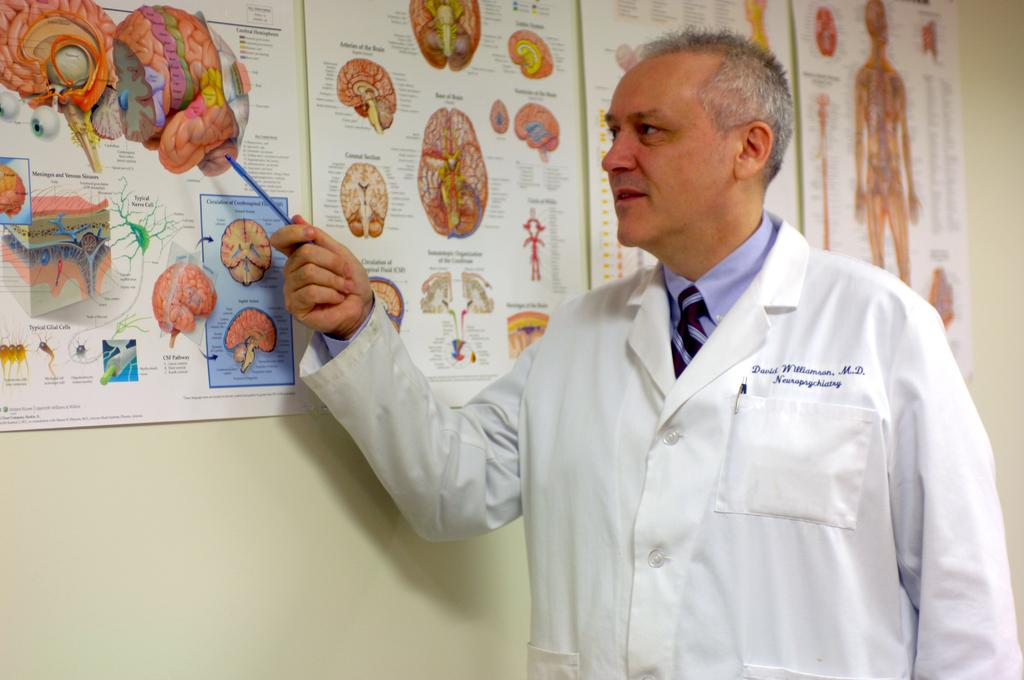Who is the person in the image? There is a man in the image. What is the man wearing? The man is wearing a white dress. What is the man holding in the image? The man is holding a pen. What can be seen on the wall in front of the man? There are posts on the wall in front of the man. What type of drum is the man playing in the image? There is no drum present in the image; the man is holding a pen. How does the man's clothing provide comfort in the image? The man's clothing, a white dress, does not provide comfort as it is not mentioned to be made of a specific material or designed for comfort. 